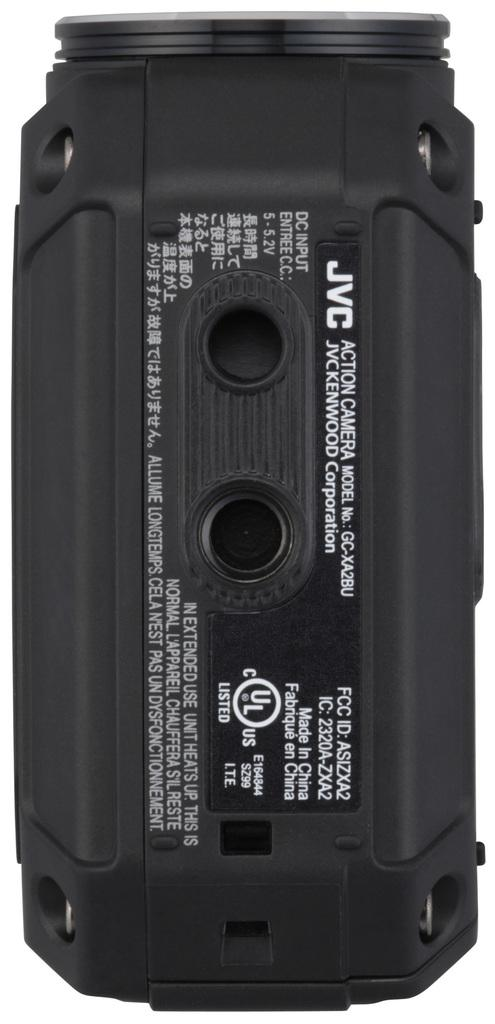What type of device can be seen in the image? There is an electronic black color device in the image. How many chickens are visible on the device in the image? There are no chickens present on the device in the image. What type of activity can be seen being performed on the device in the image? The fact provided does not mention any specific activity being performed on the device, so it cannot be determined from the image. 